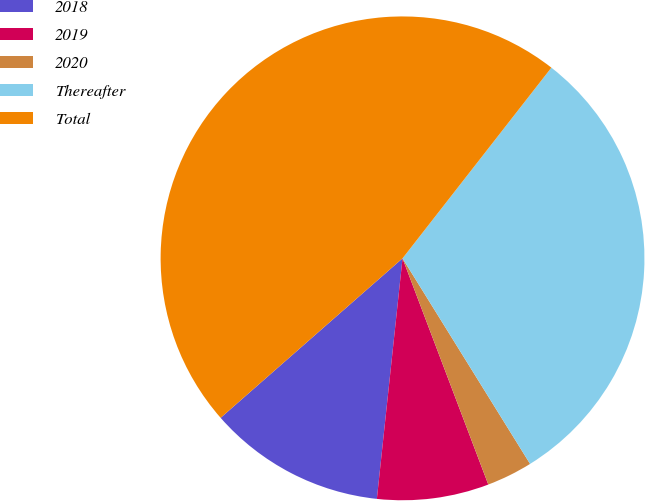Convert chart to OTSL. <chart><loc_0><loc_0><loc_500><loc_500><pie_chart><fcel>2018<fcel>2019<fcel>2020<fcel>Thereafter<fcel>Total<nl><fcel>11.85%<fcel>7.46%<fcel>3.07%<fcel>30.61%<fcel>47.0%<nl></chart> 